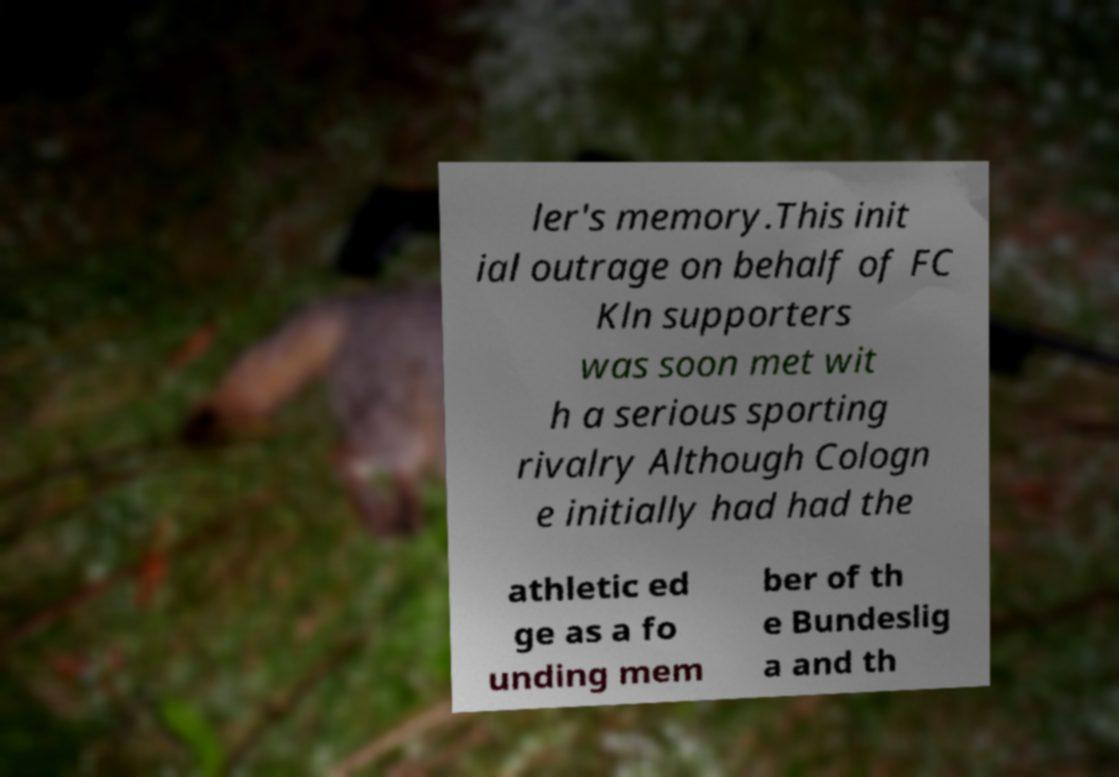Could you assist in decoding the text presented in this image and type it out clearly? ler's memory.This init ial outrage on behalf of FC Kln supporters was soon met wit h a serious sporting rivalry Although Cologn e initially had had the athletic ed ge as a fo unding mem ber of th e Bundeslig a and th 